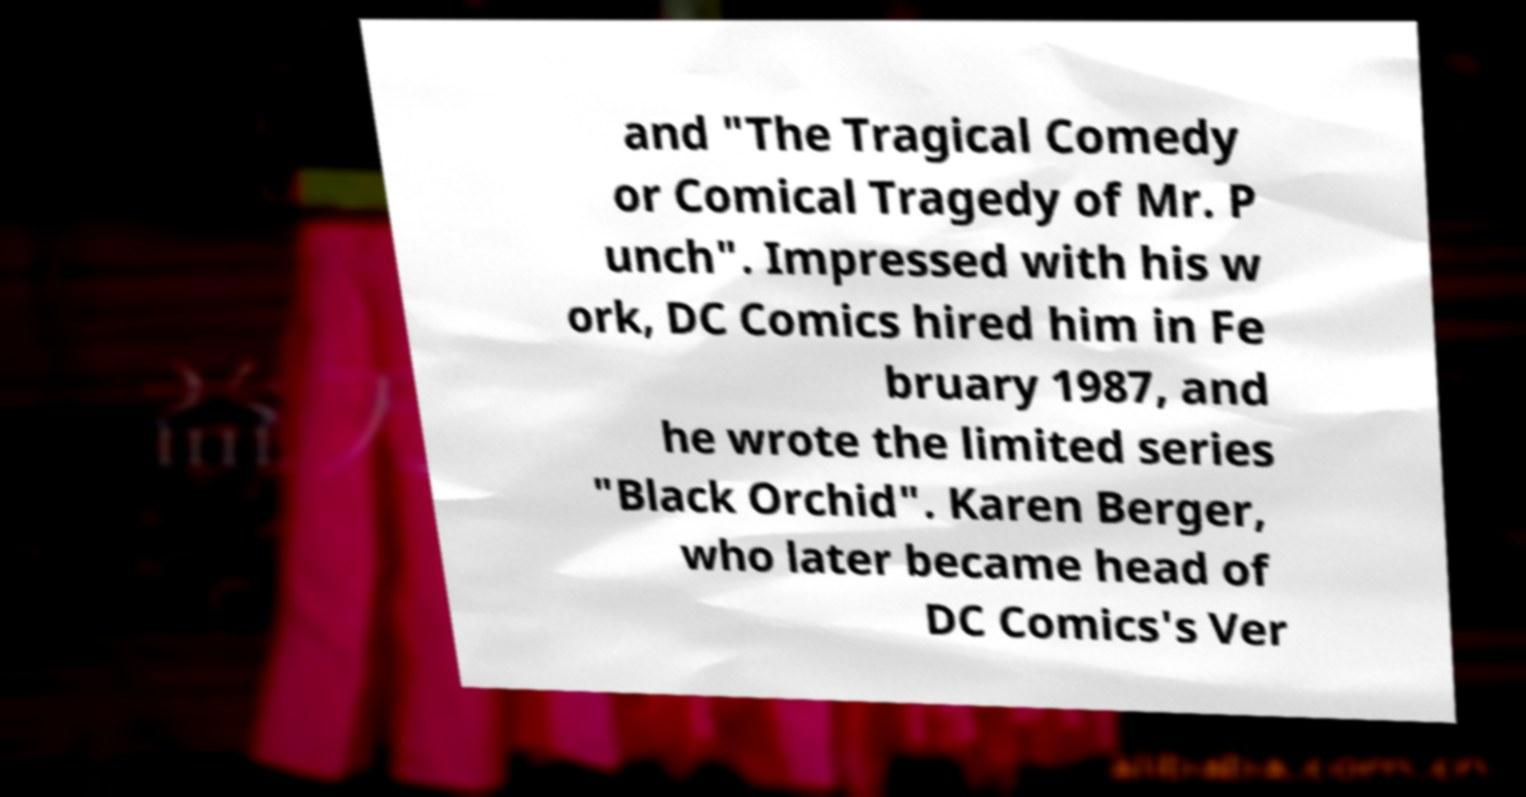For documentation purposes, I need the text within this image transcribed. Could you provide that? and "The Tragical Comedy or Comical Tragedy of Mr. P unch". Impressed with his w ork, DC Comics hired him in Fe bruary 1987, and he wrote the limited series "Black Orchid". Karen Berger, who later became head of DC Comics's Ver 